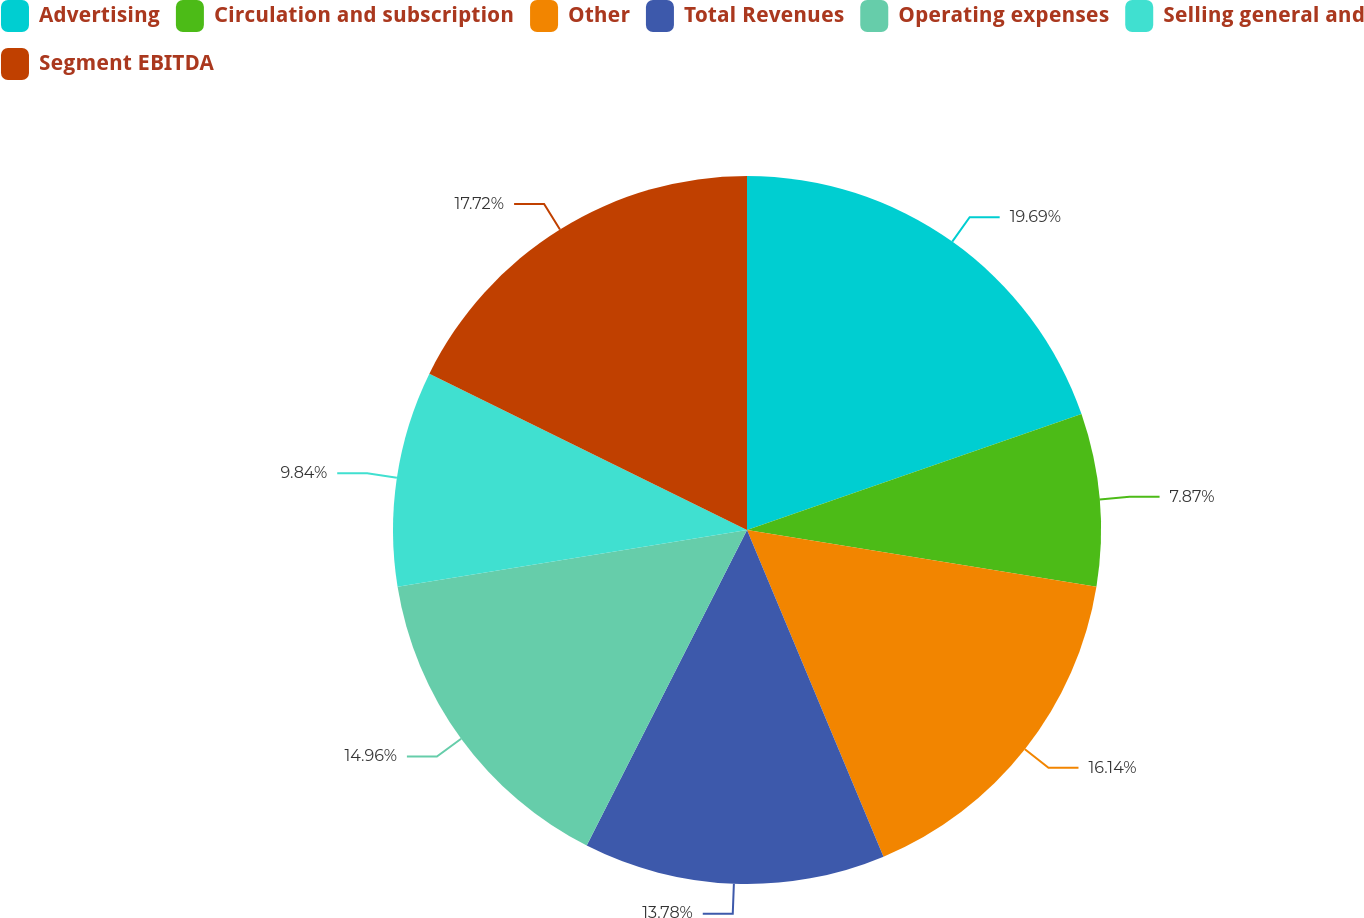Convert chart. <chart><loc_0><loc_0><loc_500><loc_500><pie_chart><fcel>Advertising<fcel>Circulation and subscription<fcel>Other<fcel>Total Revenues<fcel>Operating expenses<fcel>Selling general and<fcel>Segment EBITDA<nl><fcel>19.69%<fcel>7.87%<fcel>16.14%<fcel>13.78%<fcel>14.96%<fcel>9.84%<fcel>17.72%<nl></chart> 